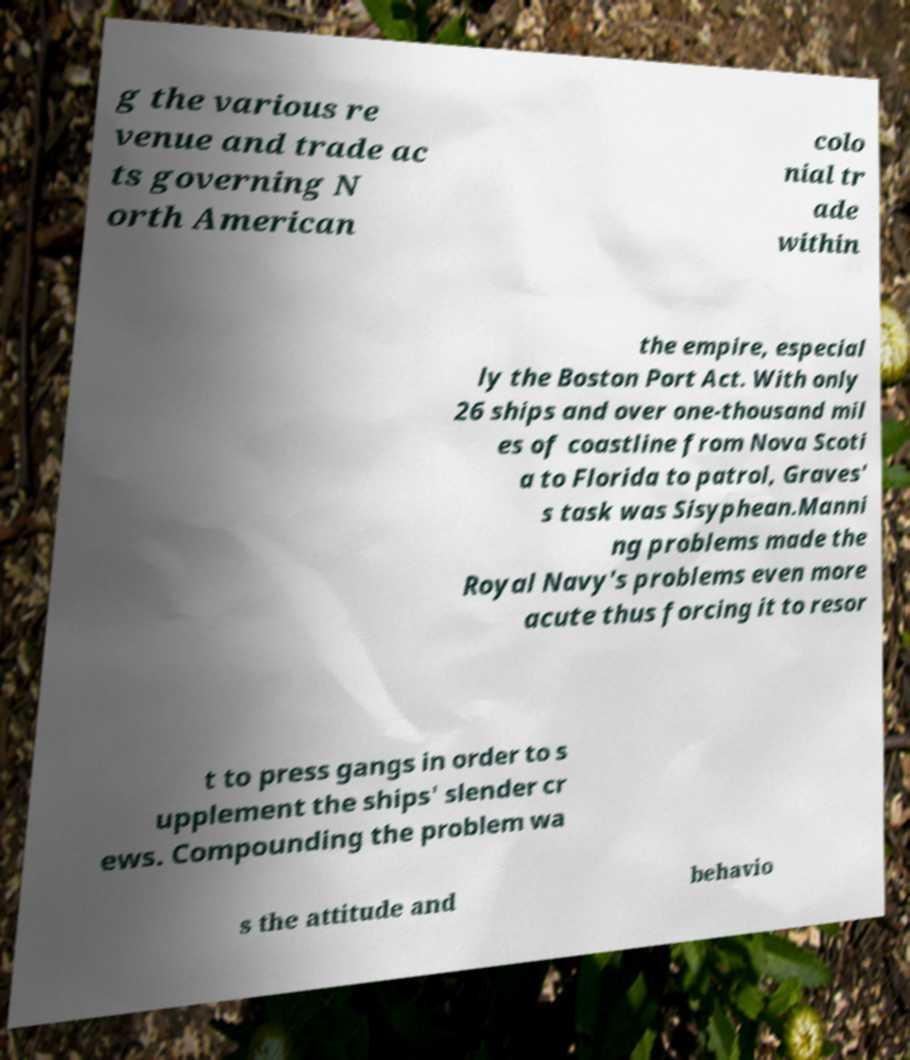Can you accurately transcribe the text from the provided image for me? g the various re venue and trade ac ts governing N orth American colo nial tr ade within the empire, especial ly the Boston Port Act. With only 26 ships and over one-thousand mil es of coastline from Nova Scoti a to Florida to patrol, Graves' s task was Sisyphean.Manni ng problems made the Royal Navy's problems even more acute thus forcing it to resor t to press gangs in order to s upplement the ships' slender cr ews. Compounding the problem wa s the attitude and behavio 